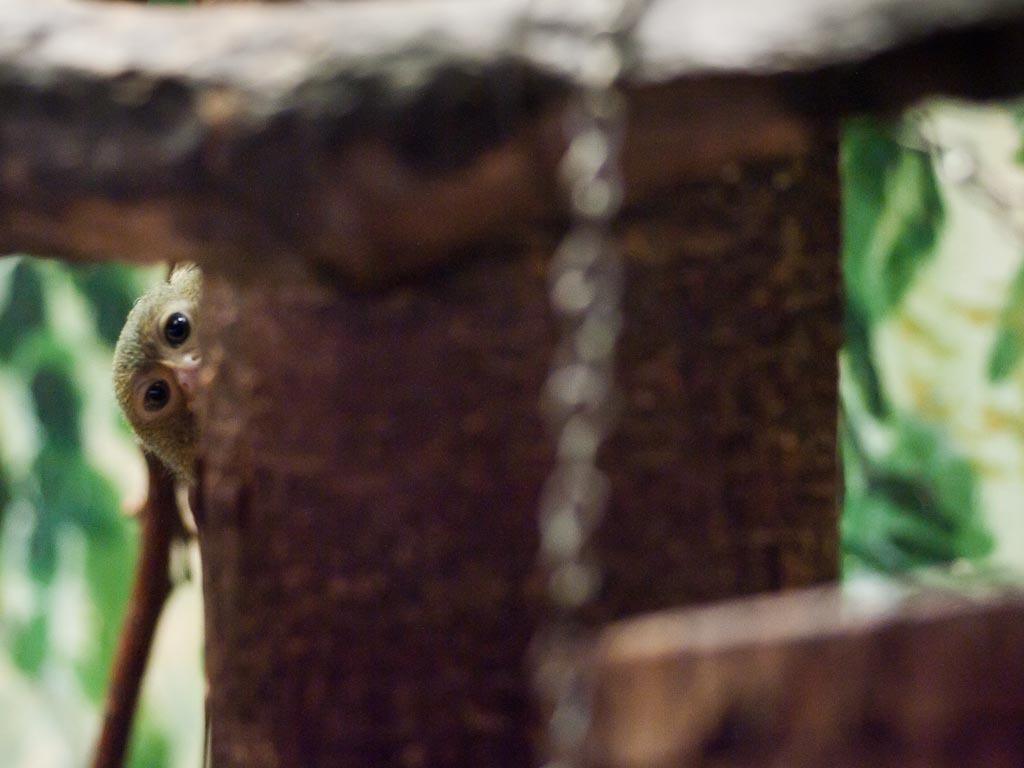What animal is present in the image? There is a monkey in the image. Where is the monkey located in relation to the tree? The monkey is behind a tree in the image. What type of structure can be seen in the image? There is wooden railing in the image. How would you describe the background of the image? The background of the image is blurry. What type of cushion is the monkey sitting on in the image? There is no cushion present in the image; the monkey is behind a tree. 